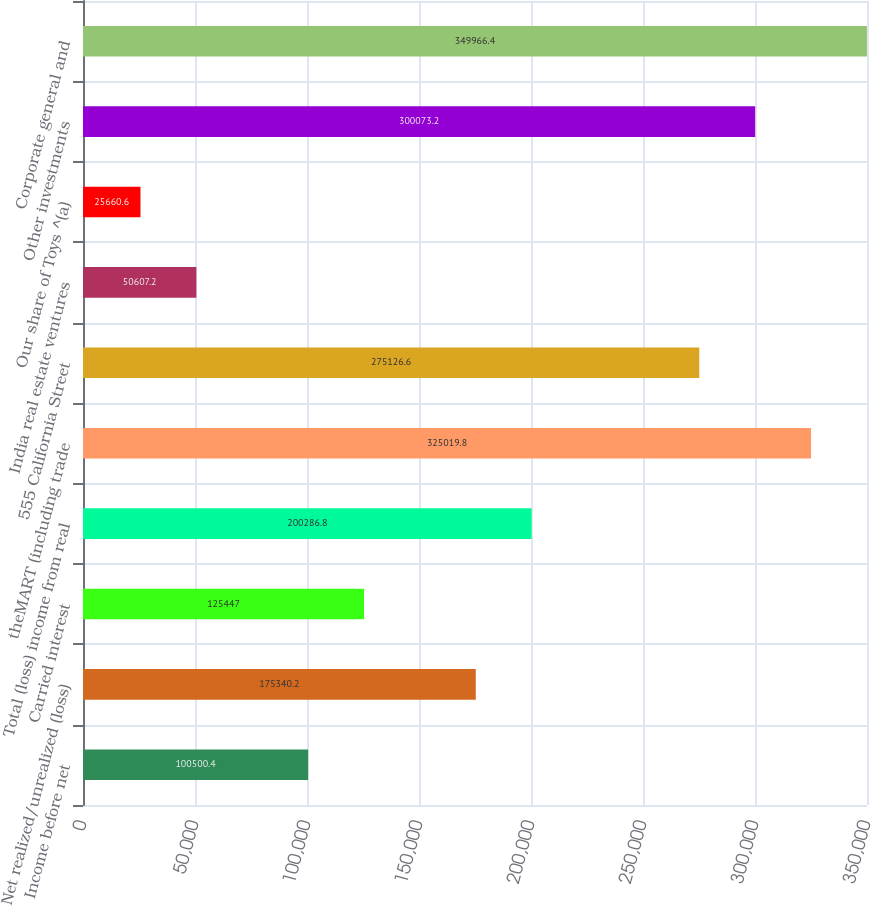Convert chart. <chart><loc_0><loc_0><loc_500><loc_500><bar_chart><fcel>Income before net<fcel>Net realized/unrealized (loss)<fcel>Carried interest<fcel>Total (loss) income from real<fcel>theMART (including trade<fcel>555 California Street<fcel>India real estate ventures<fcel>Our share of Toys ^(a)<fcel>Other investments<fcel>Corporate general and<nl><fcel>100500<fcel>175340<fcel>125447<fcel>200287<fcel>325020<fcel>275127<fcel>50607.2<fcel>25660.6<fcel>300073<fcel>349966<nl></chart> 